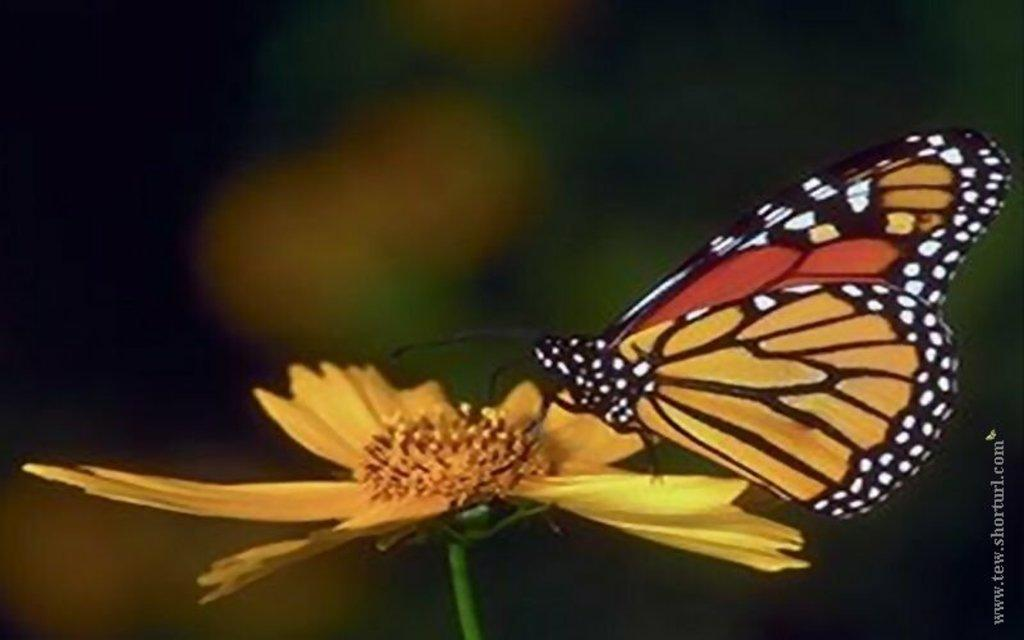What is the main subject of the image? The main subject of the image is a butterfly on a flower. What else can be seen in the image besides the butterfly and flower? There is text on the image. How does the butterfly help people in the wilderness in the image? The image does not depict the butterfly helping people in the wilderness; it simply shows a butterfly on a flower. 